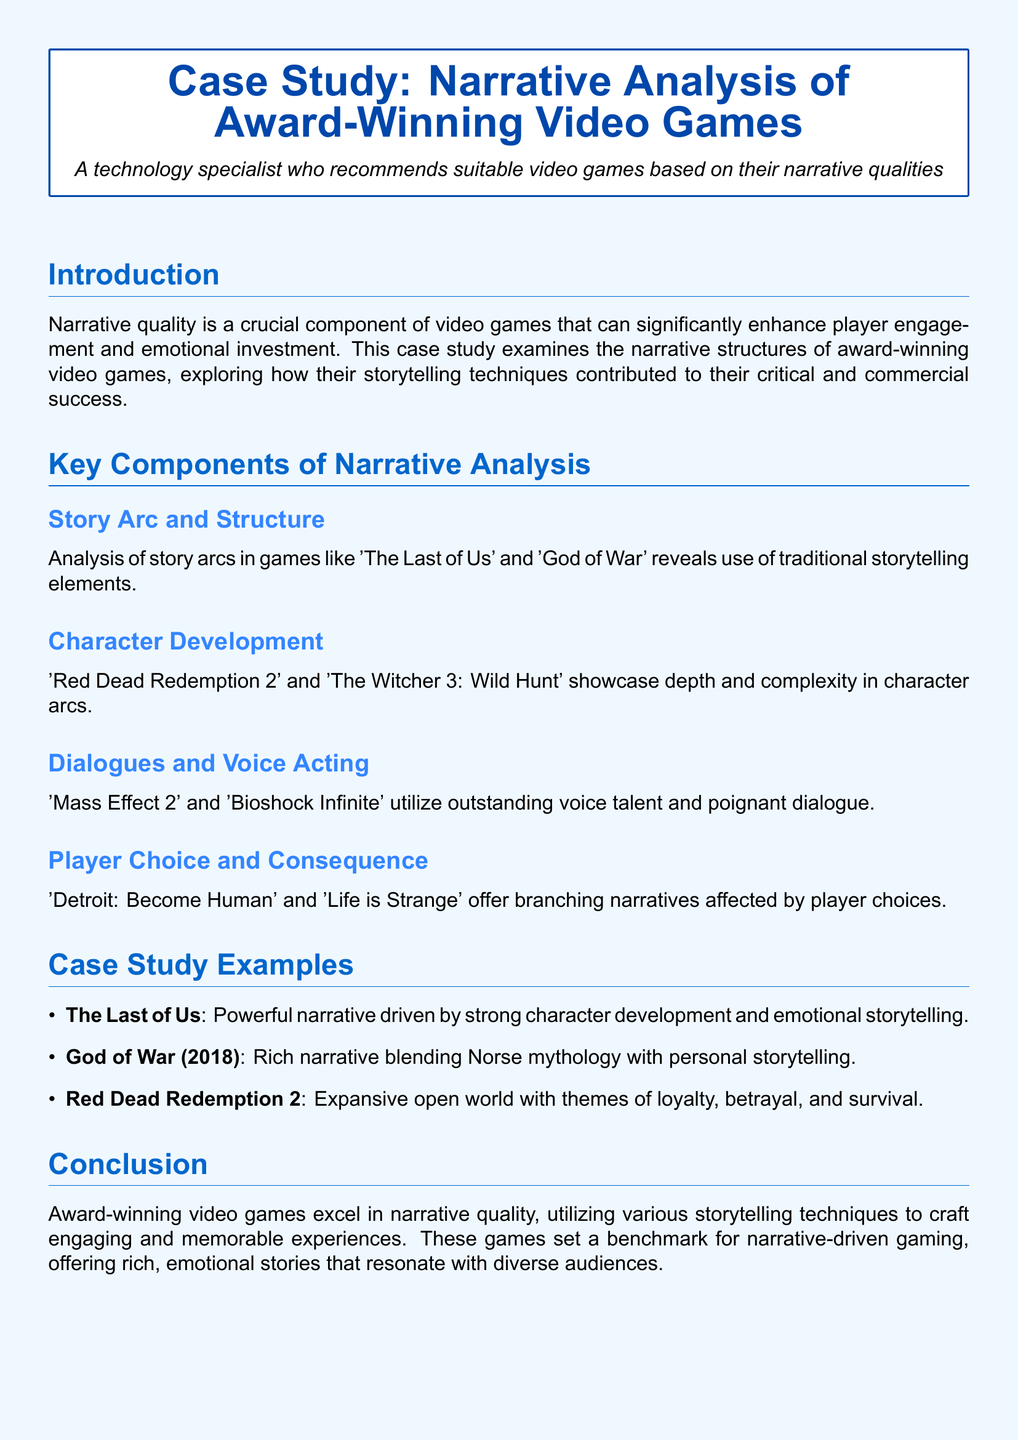what is the title of the case study? The title of the case study is presented at the top of the document within the tcolorbox.
Answer: Case Study: Narrative Analysis of Award-Winning Video Games name one award-winning game discussed in the document. The document lists several games as examples, one of which can be referenced.
Answer: The Last of Us what is a key component of narrative analysis mentioned? The document explicitly outlines components of narrative analysis in a dedicated section.
Answer: Character Development which game blends Norse mythology with personal storytelling? The document references a specific game that combines these elements, mentioned in the case study examples.
Answer: God of War (2018) how many case study examples are listed? The document features a list of case studies, and counting these gives the number of examples discussed.
Answer: Three who authored the reference for 'The Complex Characters of Red Dead Redemption 2'? The document provides a reference section that attributes authorship for the discussed topic.
Answer: IGN 